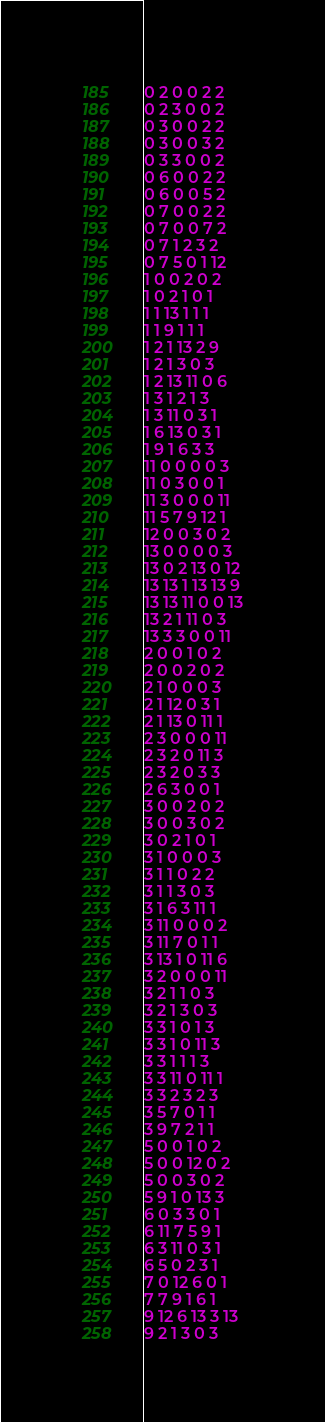Convert code to text. <code><loc_0><loc_0><loc_500><loc_500><_SQL_>0 2 0 0 2 2
0 2 3 0 0 2
0 3 0 0 2 2
0 3 0 0 3 2
0 3 3 0 0 2
0 6 0 0 2 2
0 6 0 0 5 2
0 7 0 0 2 2
0 7 0 0 7 2
0 7 1 2 3 2
0 7 5 0 1 12
1 0 0 2 0 2
1 0 2 1 0 1
1 1 13 1 1 1
1 1 9 1 1 1
1 2 1 13 2 9
1 2 1 3 0 3
1 2 13 11 0 6
1 3 1 2 1 3
1 3 11 0 3 1
1 6 13 0 3 1
1 9 1 6 3 3
11 0 0 0 0 3
11 0 3 0 0 1
11 3 0 0 0 11
11 5 7 9 12 1
12 0 0 3 0 2
13 0 0 0 0 3
13 0 2 13 0 12
13 13 1 13 13 9
13 13 11 0 0 13
13 2 1 11 0 3
13 3 3 0 0 11
2 0 0 1 0 2
2 0 0 2 0 2
2 1 0 0 0 3
2 1 12 0 3 1
2 1 13 0 11 1
2 3 0 0 0 11
2 3 2 0 11 3
2 3 2 0 3 3
2 6 3 0 0 1
3 0 0 2 0 2
3 0 0 3 0 2
3 0 2 1 0 1
3 1 0 0 0 3
3 1 1 0 2 2
3 1 1 3 0 3
3 1 6 3 11 1
3 11 0 0 0 2
3 11 7 0 1 1
3 13 1 0 11 6
3 2 0 0 0 11
3 2 1 1 0 3
3 2 1 3 0 3
3 3 1 0 1 3
3 3 1 0 11 3
3 3 1 1 1 3
3 3 11 0 11 1
3 3 2 3 2 3
3 5 7 0 1 1
3 9 7 2 1 1
5 0 0 1 0 2
5 0 0 12 0 2
5 0 0 3 0 2
5 9 1 0 13 3
6 0 3 3 0 1
6 11 7 5 9 1
6 3 11 0 3 1
6 5 0 2 3 1
7 0 12 6 0 1
7 7 9 1 6 1
9 12 6 13 3 13
9 2 1 3 0 3
</code> 